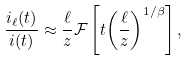Convert formula to latex. <formula><loc_0><loc_0><loc_500><loc_500>\frac { i _ { \ell } ( t ) } { i ( t ) } \approx \frac { \ell } { z } \mathcal { F } \left [ t { \left ( \frac { \ell } { z } \right ) } ^ { 1 / \beta } \right ] ,</formula> 